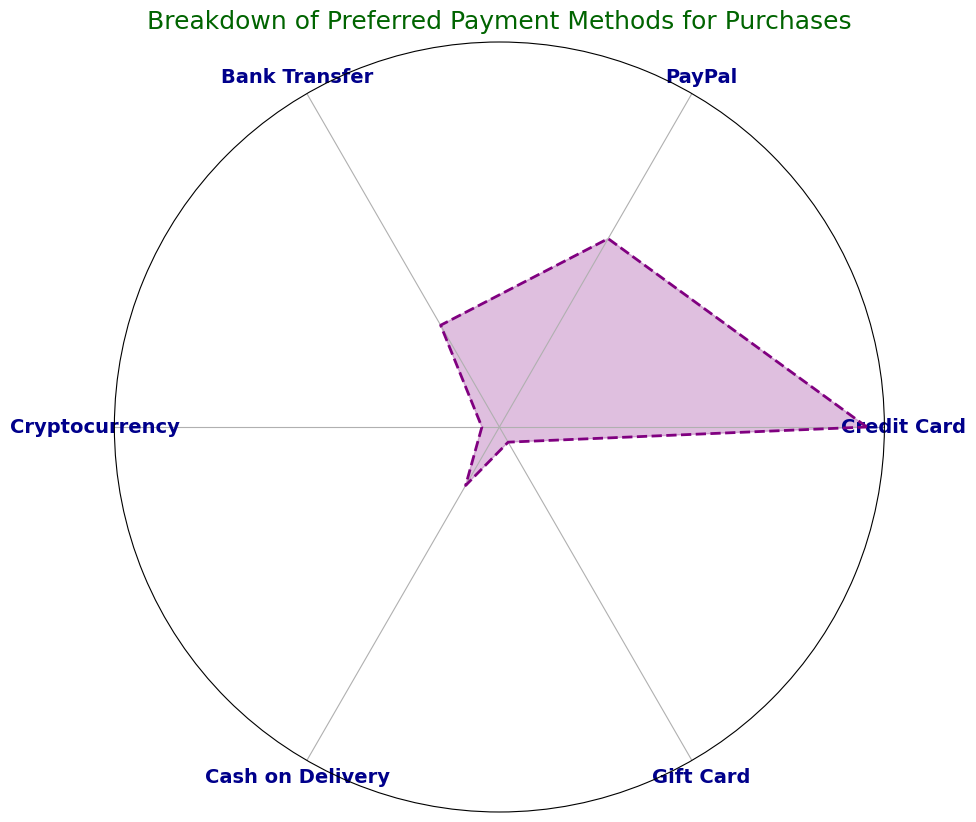What is the most preferred payment method? The Credit Card section has the highest proportion, visually the largest area on the rose chart.
Answer: Credit Card Which payment method is the least preferred? Cryptocurrency and Gift Card sections are the smallest in the rose chart. Both are 5%.
Answer: Cryptocurrency and Gift Card What is the combined percentage of payments made via PayPal and Bank Transfer? PayPal is 25% and Bank Transfer is 15%. Combining them: 25 + 15 = 40
Answer: 40% How does the use of Cash on Delivery compare to PayPal? PayPal has a larger section than Cash on Delivery. PayPal is 25%, while Cash on Delivery is 10%.
Answer: PayPal is 15% larger Which payment methods make up half of the total payments? Credit Card (40%) and PayPal (25%) account for 65%. However, Credit Card alone already accounts for 40%, which is less than half. Adding PayPal, they make up 65%, which exceeds half. Checking Bank Transfer (15%) separately, Credit Card plus Bank Transfer equals 55%, still more than half. So no exact combination equals 50%.
Answer: No exact combination equals 50% Compare the combined use of traditional payment methods (Credit Card, Bank Transfer, Cash on Delivery) to electronic methods (PayPal, Cryptocurrency, Gift Card). Traditional: Credit Card (40%), Bank Transfer (15%), Cash on Delivery (10%) = 65%. Electronic: PayPal (25%), Cryptocurrency (5%), Gift Card (5%) = 35%.
Answer: Traditional: 65%, Electronic: 35% What are the visual attributes that highlight the Credit Card as the most preferred method? The Credit Card section is the largest in the rose chart, highlighted prominently with the label clearly posted.
Answer: It has the largest area Is Bank Transfer usage greater than the combined usage of Cryptocurrency and Gift Card? Bank Transfer is 15%. Cryptocurrency and Gift Card together are 5% + 5% = 10%.
Answer: Yes, it's greater by 5% What proportion of payments are not done electronically? Electronic methods total PayPal (25%), Cryptocurrency (5%), Gift Card (5%) = 35%. Non-electronic is the rest: 100% - 35% = 65%.
Answer: 65% Which payment method has exactly double the percentage of Cash on Delivery? Cash on Delivery is 10%. Double of 10% is 20%. No method aligns with this mathematically, so none.
Answer: None 